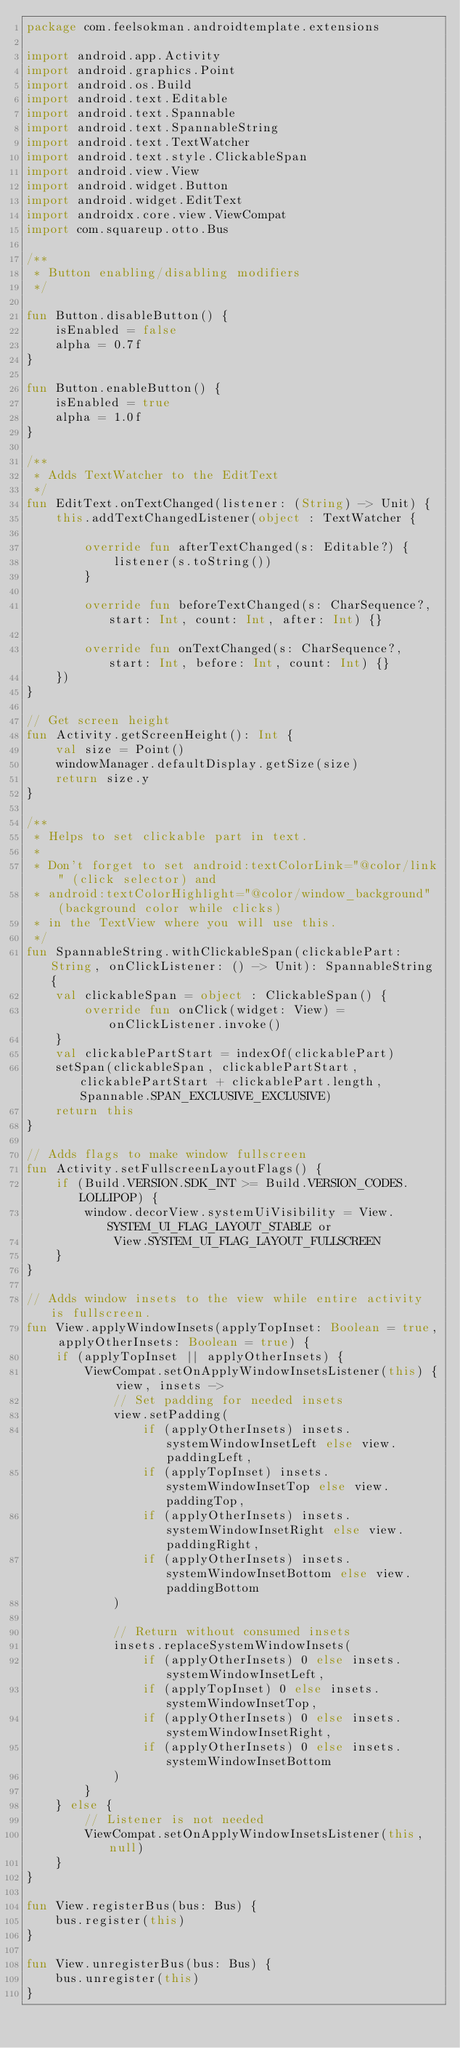Convert code to text. <code><loc_0><loc_0><loc_500><loc_500><_Kotlin_>package com.feelsokman.androidtemplate.extensions

import android.app.Activity
import android.graphics.Point
import android.os.Build
import android.text.Editable
import android.text.Spannable
import android.text.SpannableString
import android.text.TextWatcher
import android.text.style.ClickableSpan
import android.view.View
import android.widget.Button
import android.widget.EditText
import androidx.core.view.ViewCompat
import com.squareup.otto.Bus

/**
 * Button enabling/disabling modifiers
 */

fun Button.disableButton() {
    isEnabled = false
    alpha = 0.7f
}

fun Button.enableButton() {
    isEnabled = true
    alpha = 1.0f
}

/**
 * Adds TextWatcher to the EditText
 */
fun EditText.onTextChanged(listener: (String) -> Unit) {
    this.addTextChangedListener(object : TextWatcher {

        override fun afterTextChanged(s: Editable?) {
            listener(s.toString())
        }

        override fun beforeTextChanged(s: CharSequence?, start: Int, count: Int, after: Int) {}

        override fun onTextChanged(s: CharSequence?, start: Int, before: Int, count: Int) {}
    })
}

// Get screen height
fun Activity.getScreenHeight(): Int {
    val size = Point()
    windowManager.defaultDisplay.getSize(size)
    return size.y
}

/**
 * Helps to set clickable part in text.
 *
 * Don't forget to set android:textColorLink="@color/link" (click selector) and
 * android:textColorHighlight="@color/window_background" (background color while clicks)
 * in the TextView where you will use this.
 */
fun SpannableString.withClickableSpan(clickablePart: String, onClickListener: () -> Unit): SpannableString {
    val clickableSpan = object : ClickableSpan() {
        override fun onClick(widget: View) = onClickListener.invoke()
    }
    val clickablePartStart = indexOf(clickablePart)
    setSpan(clickableSpan, clickablePartStart, clickablePartStart + clickablePart.length, Spannable.SPAN_EXCLUSIVE_EXCLUSIVE)
    return this
}

// Adds flags to make window fullscreen
fun Activity.setFullscreenLayoutFlags() {
    if (Build.VERSION.SDK_INT >= Build.VERSION_CODES.LOLLIPOP) {
        window.decorView.systemUiVisibility = View.SYSTEM_UI_FLAG_LAYOUT_STABLE or
            View.SYSTEM_UI_FLAG_LAYOUT_FULLSCREEN
    }
}

// Adds window insets to the view while entire activity is fullscreen.
fun View.applyWindowInsets(applyTopInset: Boolean = true, applyOtherInsets: Boolean = true) {
    if (applyTopInset || applyOtherInsets) {
        ViewCompat.setOnApplyWindowInsetsListener(this) { view, insets ->
            // Set padding for needed insets
            view.setPadding(
                if (applyOtherInsets) insets.systemWindowInsetLeft else view.paddingLeft,
                if (applyTopInset) insets.systemWindowInsetTop else view.paddingTop,
                if (applyOtherInsets) insets.systemWindowInsetRight else view.paddingRight,
                if (applyOtherInsets) insets.systemWindowInsetBottom else view.paddingBottom
            )

            // Return without consumed insets
            insets.replaceSystemWindowInsets(
                if (applyOtherInsets) 0 else insets.systemWindowInsetLeft,
                if (applyTopInset) 0 else insets.systemWindowInsetTop,
                if (applyOtherInsets) 0 else insets.systemWindowInsetRight,
                if (applyOtherInsets) 0 else insets.systemWindowInsetBottom
            )
        }
    } else {
        // Listener is not needed
        ViewCompat.setOnApplyWindowInsetsListener(this, null)
    }
}

fun View.registerBus(bus: Bus) {
    bus.register(this)
}

fun View.unregisterBus(bus: Bus) {
    bus.unregister(this)
}
</code> 